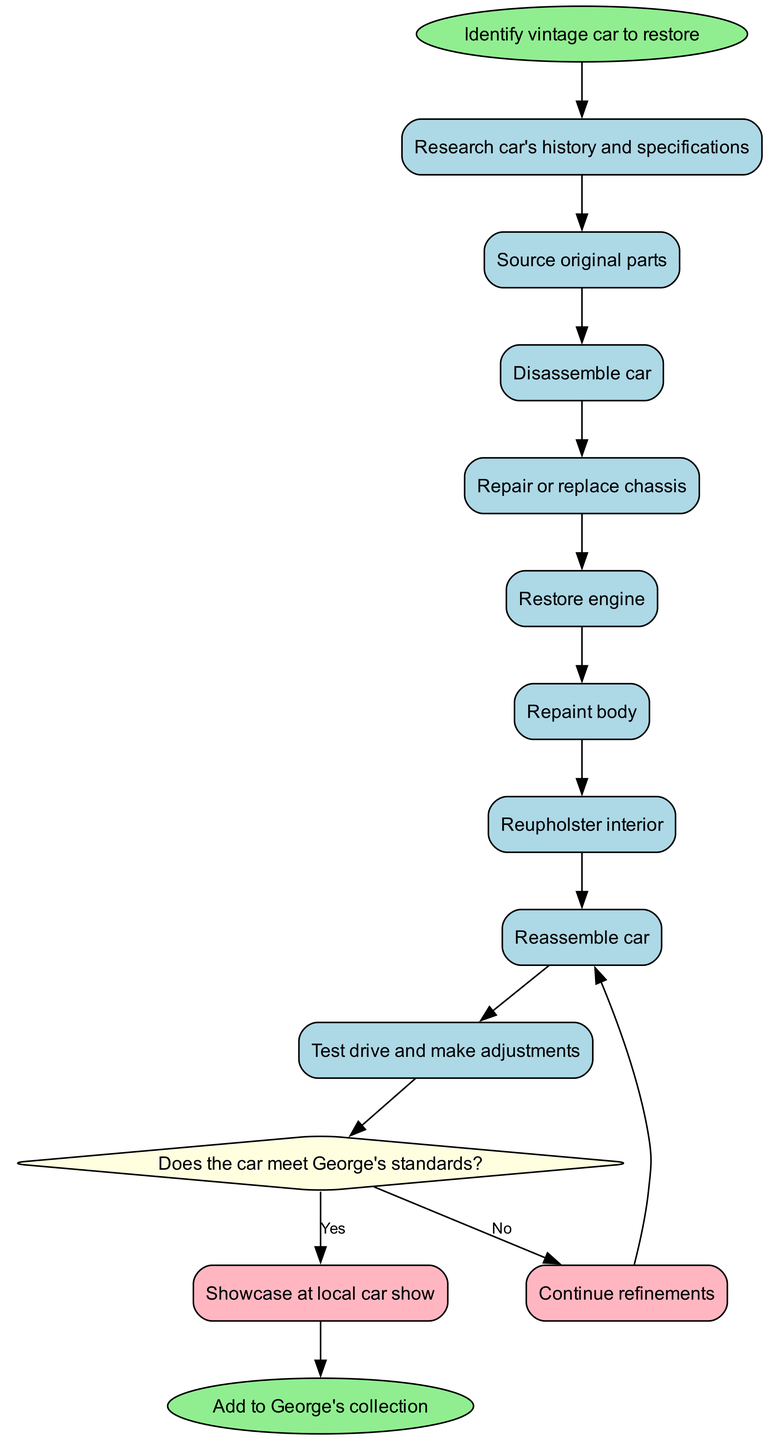What is the first activity in the restoration process? The diagram starts with the node labeled "Identify vintage car to restore." This is the first step in the process, leading to the subsequent activities.
Answer: Identify vintage car to restore How many activities are involved in restoring the vintage car? The diagram lists a total of eight activities that are sequential in the restoration process, culminating in the final step before decision-making.
Answer: 8 What activity comes after "Reupholster interior"? Following "Reupholster interior," the next activity listed is "Reassemble car," indicating the flow of actions in the restoration process.
Answer: Reassemble car What decision is made in the restoration process? The diagram incorporates a decision node that asks, "Does the car meet George's standards?" This decision directly affects the outcome of the restoration process.
Answer: Does the car meet George's standards? What happens if the car meets George's standards? If the decision taken is "Yes: Showcase at local car show," this indicates a successful outcome leading to showcasing the restored car, concluding the project positively.
Answer: Showcase at local car show What comes before "Repair or replace chassis"? The activity that comes just before "Repair or replace chassis" is "Disassemble car," which is essential for accessing the chassis during the restoration process.
Answer: Disassemble car What is the end point of the activity diagram? The diagram indicates the endpoint with the node labeled "Add to George's collection," which signifies the successful conclusion of the car restoration process.
Answer: Add to George's collection What does the decision node signify in relation to the branches? The decision node, based on whether the car meets George's standards, leads to two branches: one for successful showcasing and another for further refinements, signifying the path taken based on the car's condition.
Answer: The decision node signifies a quality check leading to two possible pathways What is the color of the start node in the diagram? The start node is colored light green, as specified in the diagram attributes, which visually distinguishes it as the beginning of the process.
Answer: Light green 